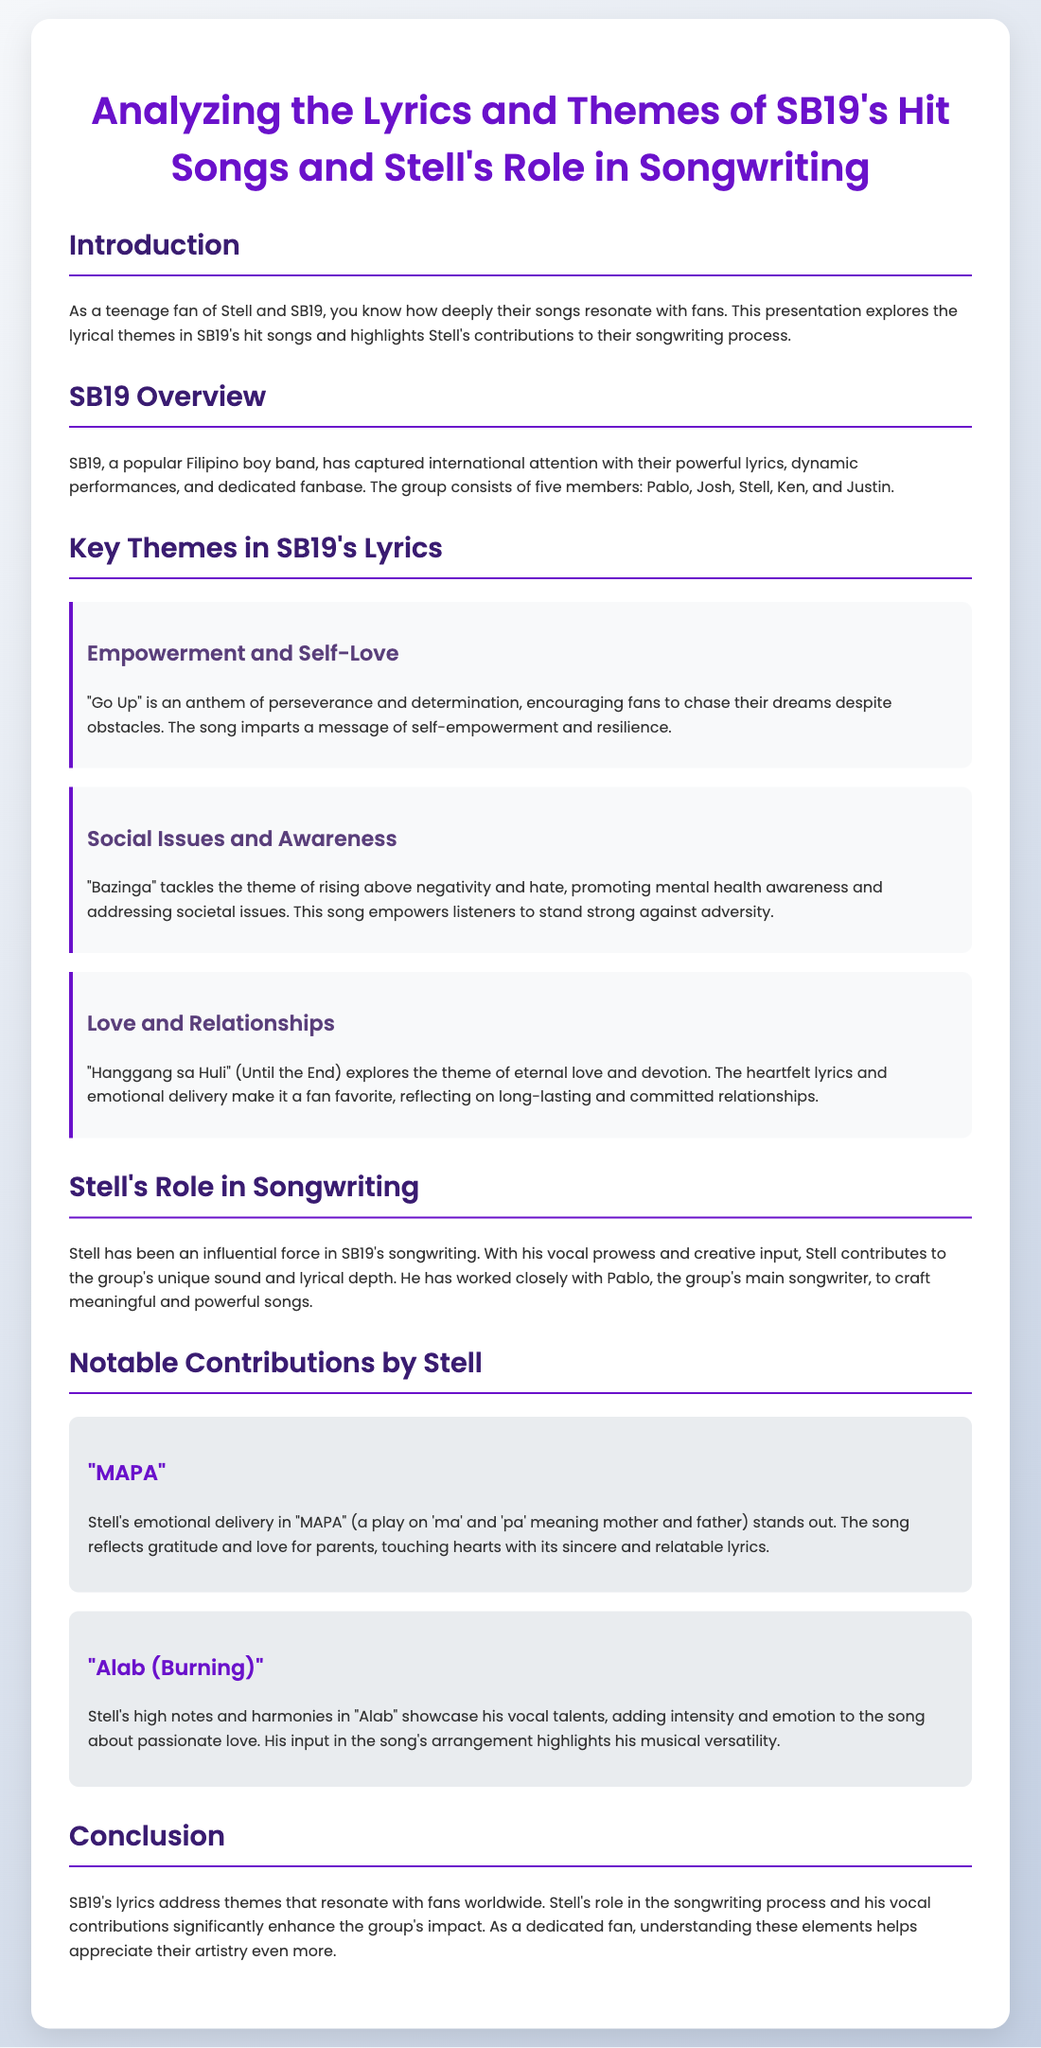What are the names of SB19's members? The names of SB19's members are Pablo, Josh, Stell, Ken, and Justin.
Answer: Pablo, Josh, Stell, Ken, and Justin What is the theme of "Go Up"? "Go Up" is an anthem of perseverance and determination, encouraging fans to chase their dreams despite obstacles.
Answer: Empowerment and self-love Which song addresses mental health awareness? "Bazinga" tackles the theme of rising above negativity and hate, promoting mental health awareness.
Answer: Bazinga Who is the main songwriter in SB19? Pablo is the group's main songwriter.
Answer: Pablo What does "MAPA" mean? "MAPA" is a play on 'ma' and 'pa' meaning mother and father.
Answer: Mother and father What does Stell contribute to the group? Stell contributes to the group's unique sound and lyrical depth.
Answer: Unique sound and lyrical depth How does Stell enhance "Alab"? Stell's high notes and harmonies in "Alab" showcase his vocal talents.
Answer: High notes and harmonies What is the overarching theme of SB19's lyrics? SB19's lyrics address themes that resonate with fans worldwide.
Answer: Themes that resonate with fans worldwide 